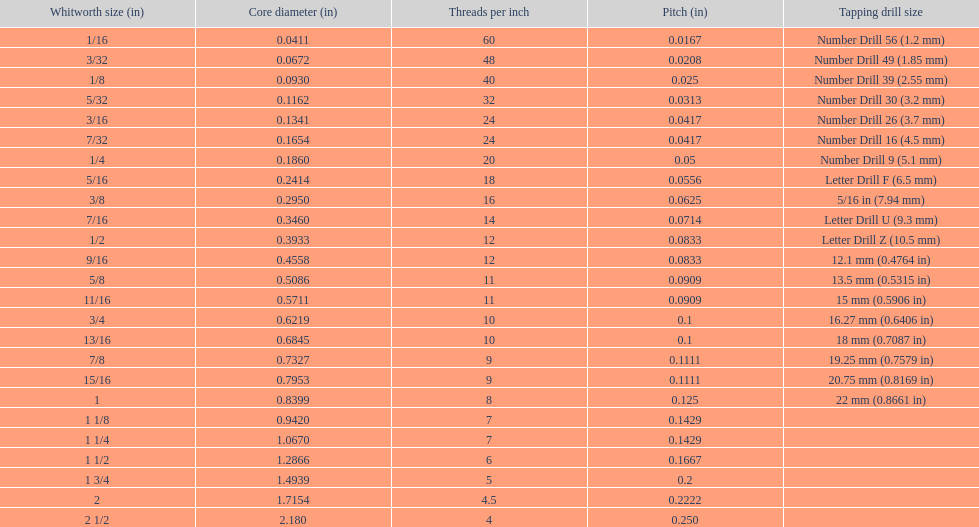What is the subsequent whitworth size (inches) smaller than 1/8? 5/32. Parse the table in full. {'header': ['Whitworth size (in)', 'Core diameter (in)', 'Threads per\xa0inch', 'Pitch (in)', 'Tapping drill size'], 'rows': [['1/16', '0.0411', '60', '0.0167', 'Number Drill 56 (1.2\xa0mm)'], ['3/32', '0.0672', '48', '0.0208', 'Number Drill 49 (1.85\xa0mm)'], ['1/8', '0.0930', '40', '0.025', 'Number Drill 39 (2.55\xa0mm)'], ['5/32', '0.1162', '32', '0.0313', 'Number Drill 30 (3.2\xa0mm)'], ['3/16', '0.1341', '24', '0.0417', 'Number Drill 26 (3.7\xa0mm)'], ['7/32', '0.1654', '24', '0.0417', 'Number Drill 16 (4.5\xa0mm)'], ['1/4', '0.1860', '20', '0.05', 'Number Drill 9 (5.1\xa0mm)'], ['5/16', '0.2414', '18', '0.0556', 'Letter Drill F (6.5\xa0mm)'], ['3/8', '0.2950', '16', '0.0625', '5/16\xa0in (7.94\xa0mm)'], ['7/16', '0.3460', '14', '0.0714', 'Letter Drill U (9.3\xa0mm)'], ['1/2', '0.3933', '12', '0.0833', 'Letter Drill Z (10.5\xa0mm)'], ['9/16', '0.4558', '12', '0.0833', '12.1\xa0mm (0.4764\xa0in)'], ['5/8', '0.5086', '11', '0.0909', '13.5\xa0mm (0.5315\xa0in)'], ['11/16', '0.5711', '11', '0.0909', '15\xa0mm (0.5906\xa0in)'], ['3/4', '0.6219', '10', '0.1', '16.27\xa0mm (0.6406\xa0in)'], ['13/16', '0.6845', '10', '0.1', '18\xa0mm (0.7087\xa0in)'], ['7/8', '0.7327', '9', '0.1111', '19.25\xa0mm (0.7579\xa0in)'], ['15/16', '0.7953', '9', '0.1111', '20.75\xa0mm (0.8169\xa0in)'], ['1', '0.8399', '8', '0.125', '22\xa0mm (0.8661\xa0in)'], ['1 1/8', '0.9420', '7', '0.1429', ''], ['1 1/4', '1.0670', '7', '0.1429', ''], ['1 1/2', '1.2866', '6', '0.1667', ''], ['1 3/4', '1.4939', '5', '0.2', ''], ['2', '1.7154', '4.5', '0.2222', ''], ['2 1/2', '2.180', '4', '0.250', '']]} 